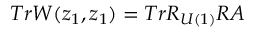Convert formula to latex. <formula><loc_0><loc_0><loc_500><loc_500>T r W ( z _ { 1 } , z _ { 1 } ) = T r R _ { U ( 1 ) } R A</formula> 